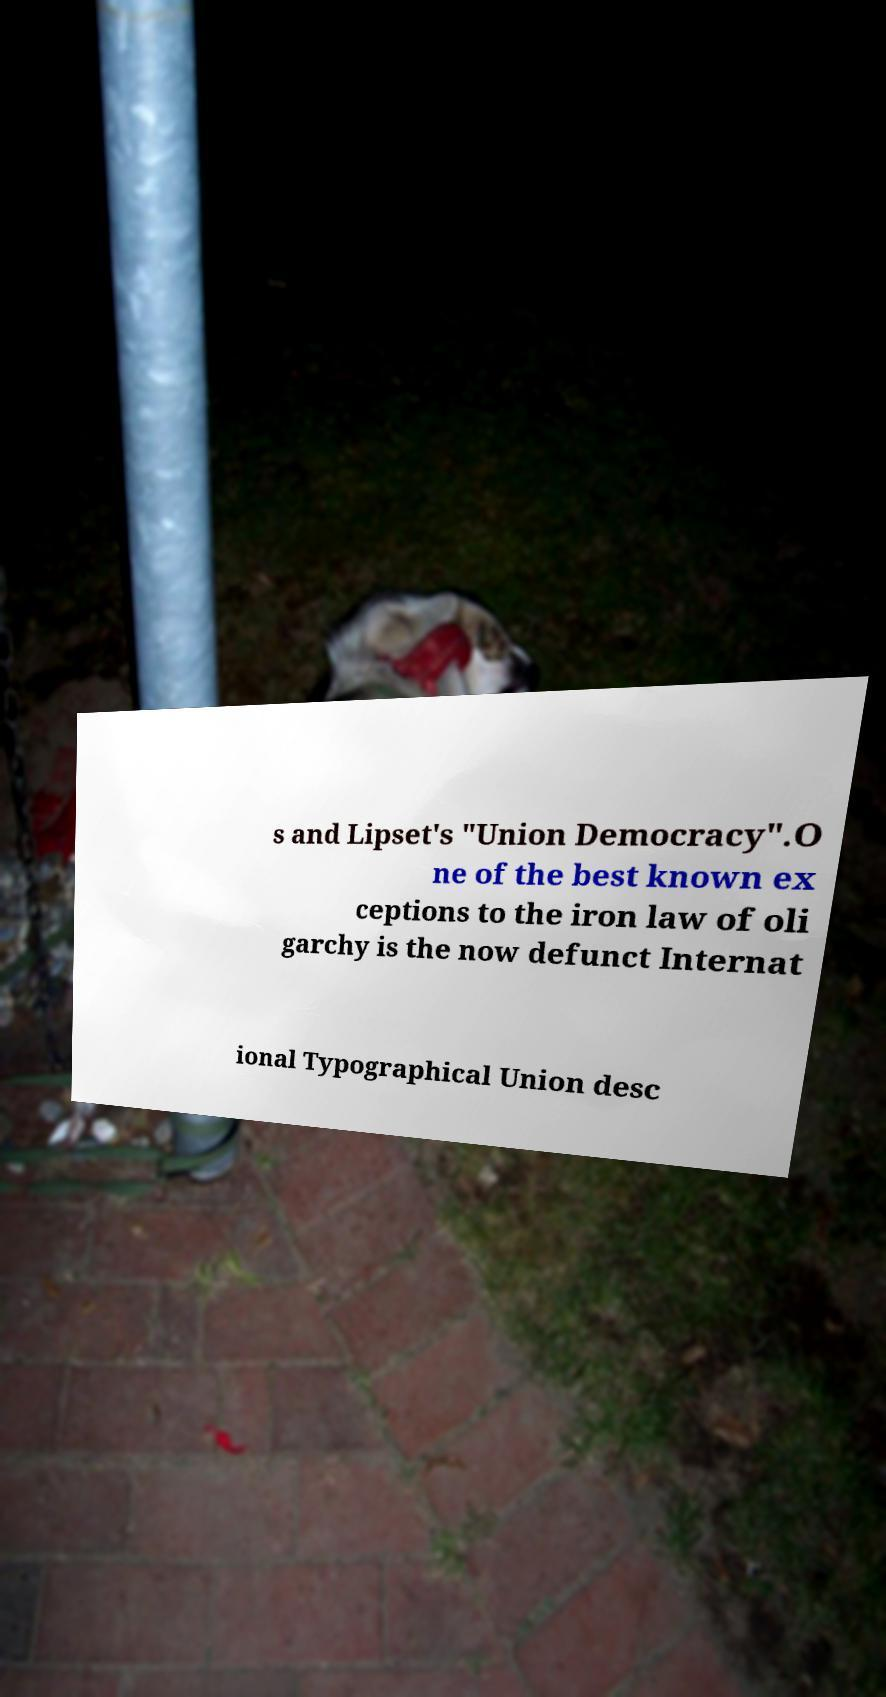Please identify and transcribe the text found in this image. s and Lipset's "Union Democracy".O ne of the best known ex ceptions to the iron law of oli garchy is the now defunct Internat ional Typographical Union desc 